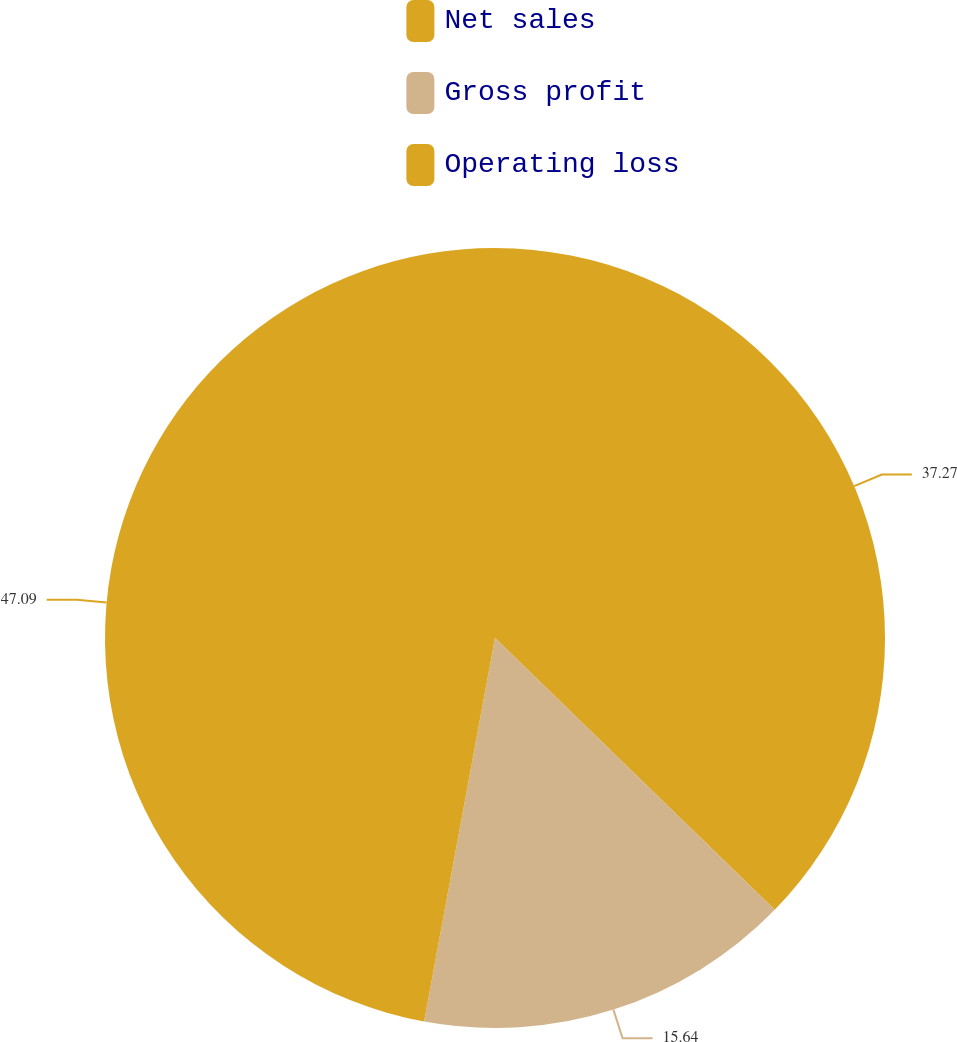Convert chart. <chart><loc_0><loc_0><loc_500><loc_500><pie_chart><fcel>Net sales<fcel>Gross profit<fcel>Operating loss<nl><fcel>37.27%<fcel>15.64%<fcel>47.09%<nl></chart> 